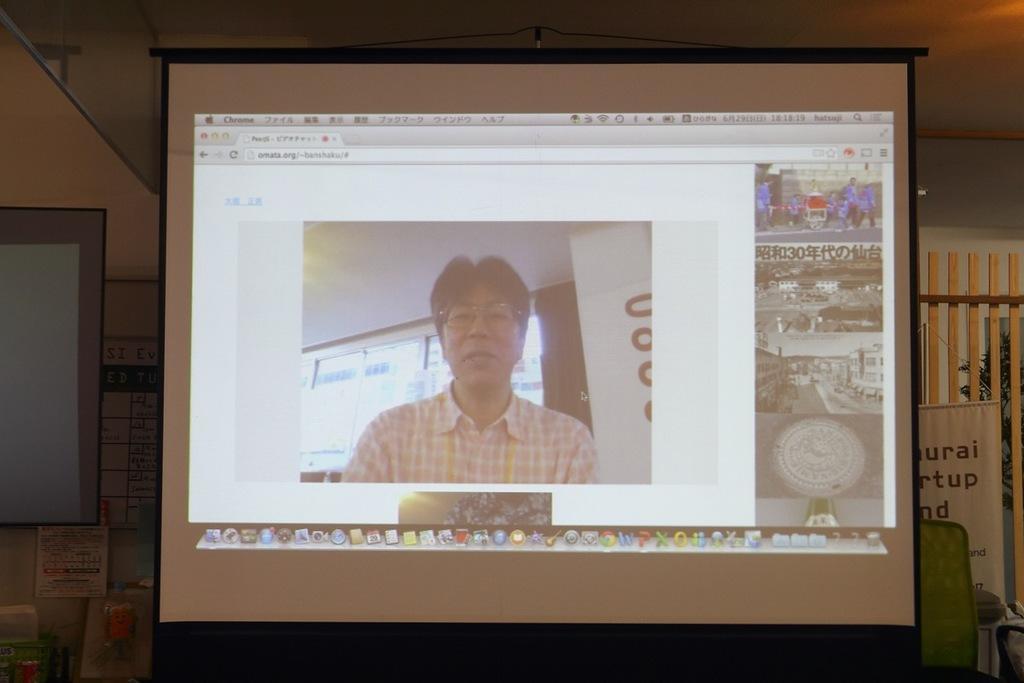Please provide a concise description of this image. In this image I can see a projector screen in the centre and on it I can see few pictures of people and of places. On the right side of it I can see a green colour thing, a whiteboard, wooden fencing and few other stuffs. On the left side of the projector screen I can see one more screen, few boards and few other stuffs. 